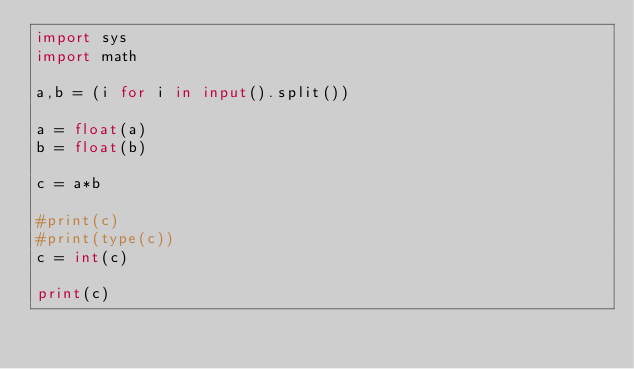Convert code to text. <code><loc_0><loc_0><loc_500><loc_500><_Python_>import sys
import math

a,b = (i for i in input().split())

a = float(a)
b = float(b)

c = a*b

#print(c)
#print(type(c))
c = int(c)

print(c)

    
    
    


</code> 